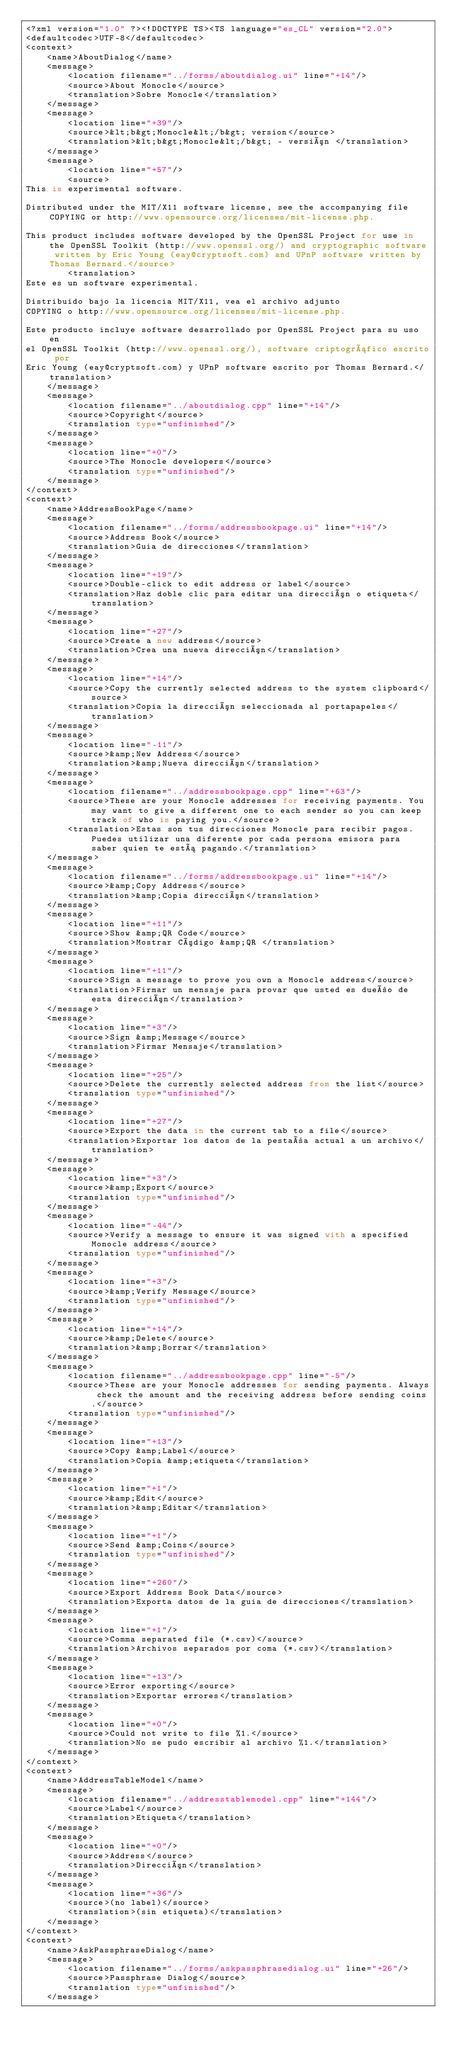Convert code to text. <code><loc_0><loc_0><loc_500><loc_500><_TypeScript_><?xml version="1.0" ?><!DOCTYPE TS><TS language="es_CL" version="2.0">
<defaultcodec>UTF-8</defaultcodec>
<context>
    <name>AboutDialog</name>
    <message>
        <location filename="../forms/aboutdialog.ui" line="+14"/>
        <source>About Monocle</source>
        <translation>Sobre Monocle</translation>
    </message>
    <message>
        <location line="+39"/>
        <source>&lt;b&gt;Monocle&lt;/b&gt; version</source>
        <translation>&lt;b&gt;Monocle&lt;/b&gt; - versión </translation>
    </message>
    <message>
        <location line="+57"/>
        <source>
This is experimental software.

Distributed under the MIT/X11 software license, see the accompanying file COPYING or http://www.opensource.org/licenses/mit-license.php.

This product includes software developed by the OpenSSL Project for use in the OpenSSL Toolkit (http://www.openssl.org/) and cryptographic software written by Eric Young (eay@cryptsoft.com) and UPnP software written by Thomas Bernard.</source>
        <translation>
Este es un software experimental.

Distribuido bajo la licencia MIT/X11, vea el archivo adjunto
COPYING o http://www.opensource.org/licenses/mit-license.php.

Este producto incluye software desarrollado por OpenSSL Project para su uso en
el OpenSSL Toolkit (http://www.openssl.org/), software criptográfico escrito por
Eric Young (eay@cryptsoft.com) y UPnP software escrito por Thomas Bernard.</translation>
    </message>
    <message>
        <location filename="../aboutdialog.cpp" line="+14"/>
        <source>Copyright</source>
        <translation type="unfinished"/>
    </message>
    <message>
        <location line="+0"/>
        <source>The Monocle developers</source>
        <translation type="unfinished"/>
    </message>
</context>
<context>
    <name>AddressBookPage</name>
    <message>
        <location filename="../forms/addressbookpage.ui" line="+14"/>
        <source>Address Book</source>
        <translation>Guia de direcciones</translation>
    </message>
    <message>
        <location line="+19"/>
        <source>Double-click to edit address or label</source>
        <translation>Haz doble clic para editar una dirección o etiqueta</translation>
    </message>
    <message>
        <location line="+27"/>
        <source>Create a new address</source>
        <translation>Crea una nueva dirección</translation>
    </message>
    <message>
        <location line="+14"/>
        <source>Copy the currently selected address to the system clipboard</source>
        <translation>Copia la dirección seleccionada al portapapeles</translation>
    </message>
    <message>
        <location line="-11"/>
        <source>&amp;New Address</source>
        <translation>&amp;Nueva dirección</translation>
    </message>
    <message>
        <location filename="../addressbookpage.cpp" line="+63"/>
        <source>These are your Monocle addresses for receiving payments. You may want to give a different one to each sender so you can keep track of who is paying you.</source>
        <translation>Estas son tus direcciones Monocle para recibir pagos. Puedes utilizar una diferente por cada persona emisora para saber quien te está pagando.</translation>
    </message>
    <message>
        <location filename="../forms/addressbookpage.ui" line="+14"/>
        <source>&amp;Copy Address</source>
        <translation>&amp;Copia dirección</translation>
    </message>
    <message>
        <location line="+11"/>
        <source>Show &amp;QR Code</source>
        <translation>Mostrar Código &amp;QR </translation>
    </message>
    <message>
        <location line="+11"/>
        <source>Sign a message to prove you own a Monocle address</source>
        <translation>Firmar un mensaje para provar que usted es dueño de esta dirección</translation>
    </message>
    <message>
        <location line="+3"/>
        <source>Sign &amp;Message</source>
        <translation>Firmar Mensaje</translation>
    </message>
    <message>
        <location line="+25"/>
        <source>Delete the currently selected address from the list</source>
        <translation type="unfinished"/>
    </message>
    <message>
        <location line="+27"/>
        <source>Export the data in the current tab to a file</source>
        <translation>Exportar los datos de la pestaña actual a un archivo</translation>
    </message>
    <message>
        <location line="+3"/>
        <source>&amp;Export</source>
        <translation type="unfinished"/>
    </message>
    <message>
        <location line="-44"/>
        <source>Verify a message to ensure it was signed with a specified Monocle address</source>
        <translation type="unfinished"/>
    </message>
    <message>
        <location line="+3"/>
        <source>&amp;Verify Message</source>
        <translation type="unfinished"/>
    </message>
    <message>
        <location line="+14"/>
        <source>&amp;Delete</source>
        <translation>&amp;Borrar</translation>
    </message>
    <message>
        <location filename="../addressbookpage.cpp" line="-5"/>
        <source>These are your Monocle addresses for sending payments. Always check the amount and the receiving address before sending coins.</source>
        <translation type="unfinished"/>
    </message>
    <message>
        <location line="+13"/>
        <source>Copy &amp;Label</source>
        <translation>Copia &amp;etiqueta</translation>
    </message>
    <message>
        <location line="+1"/>
        <source>&amp;Edit</source>
        <translation>&amp;Editar</translation>
    </message>
    <message>
        <location line="+1"/>
        <source>Send &amp;Coins</source>
        <translation type="unfinished"/>
    </message>
    <message>
        <location line="+260"/>
        <source>Export Address Book Data</source>
        <translation>Exporta datos de la guia de direcciones</translation>
    </message>
    <message>
        <location line="+1"/>
        <source>Comma separated file (*.csv)</source>
        <translation>Archivos separados por coma (*.csv)</translation>
    </message>
    <message>
        <location line="+13"/>
        <source>Error exporting</source>
        <translation>Exportar errores</translation>
    </message>
    <message>
        <location line="+0"/>
        <source>Could not write to file %1.</source>
        <translation>No se pudo escribir al archivo %1.</translation>
    </message>
</context>
<context>
    <name>AddressTableModel</name>
    <message>
        <location filename="../addresstablemodel.cpp" line="+144"/>
        <source>Label</source>
        <translation>Etiqueta</translation>
    </message>
    <message>
        <location line="+0"/>
        <source>Address</source>
        <translation>Dirección</translation>
    </message>
    <message>
        <location line="+36"/>
        <source>(no label)</source>
        <translation>(sin etiqueta)</translation>
    </message>
</context>
<context>
    <name>AskPassphraseDialog</name>
    <message>
        <location filename="../forms/askpassphrasedialog.ui" line="+26"/>
        <source>Passphrase Dialog</source>
        <translation type="unfinished"/>
    </message></code> 